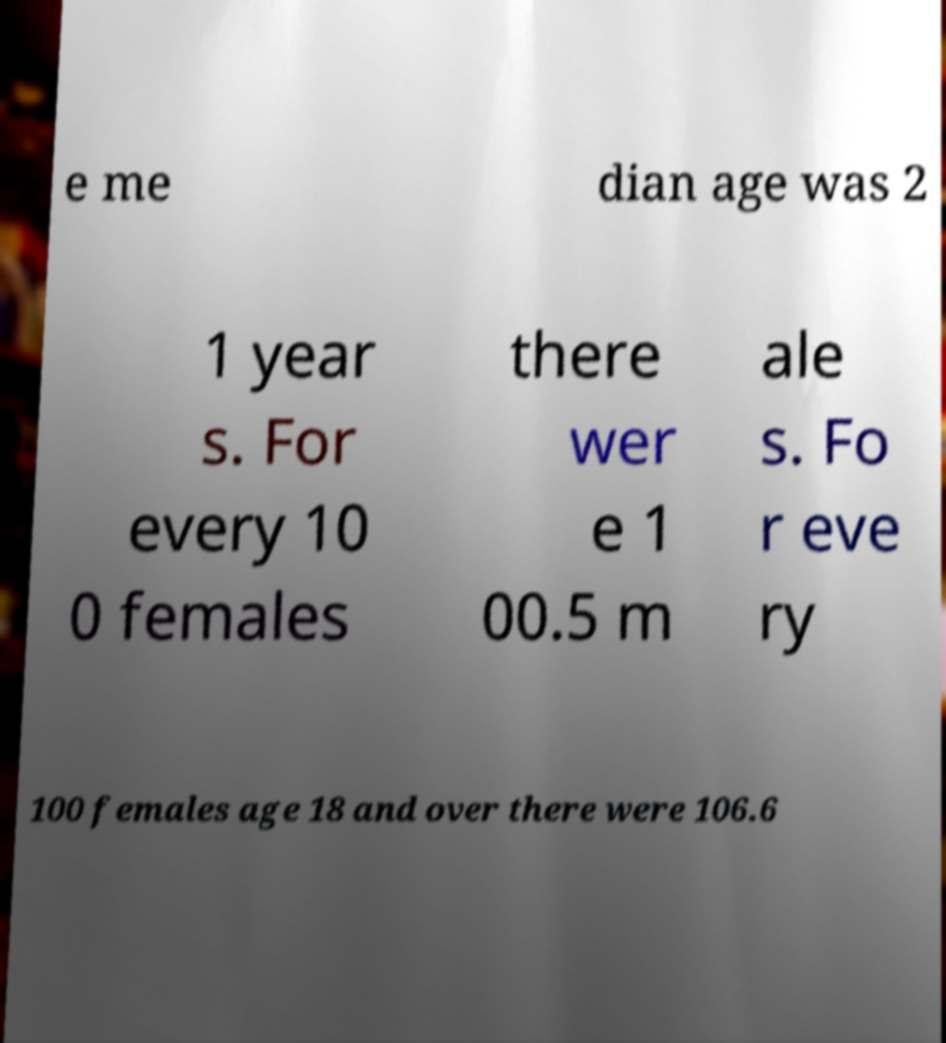For documentation purposes, I need the text within this image transcribed. Could you provide that? e me dian age was 2 1 year s. For every 10 0 females there wer e 1 00.5 m ale s. Fo r eve ry 100 females age 18 and over there were 106.6 